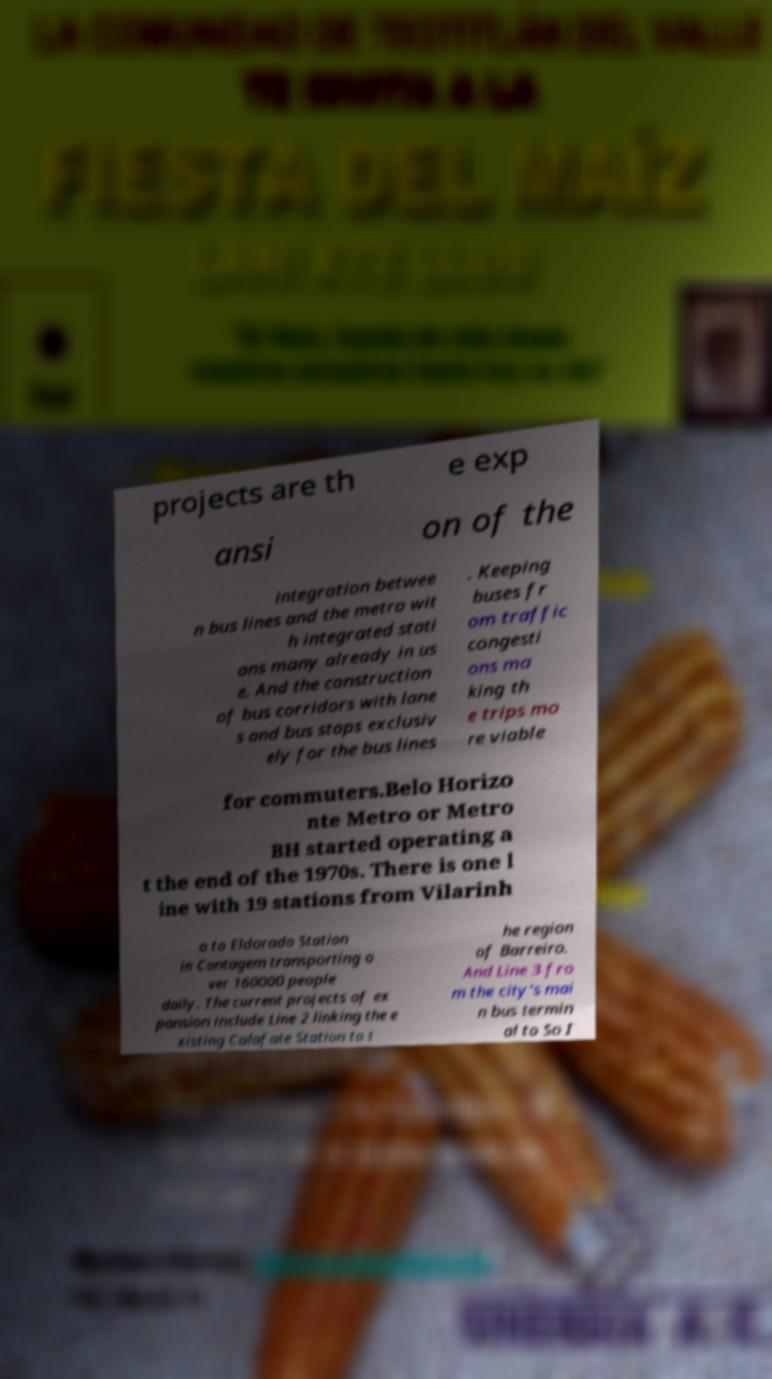For documentation purposes, I need the text within this image transcribed. Could you provide that? projects are th e exp ansi on of the integration betwee n bus lines and the metro wit h integrated stati ons many already in us e. And the construction of bus corridors with lane s and bus stops exclusiv ely for the bus lines . Keeping buses fr om traffic congesti ons ma king th e trips mo re viable for commuters.Belo Horizo nte Metro or Metro BH started operating a t the end of the 1970s. There is one l ine with 19 stations from Vilarinh o to Eldorado Station in Contagem transporting o ver 160000 people daily. The current projects of ex pansion include Line 2 linking the e xisting Calafate Station to t he region of Barreiro. And Line 3 fro m the city's mai n bus termin al to So I 